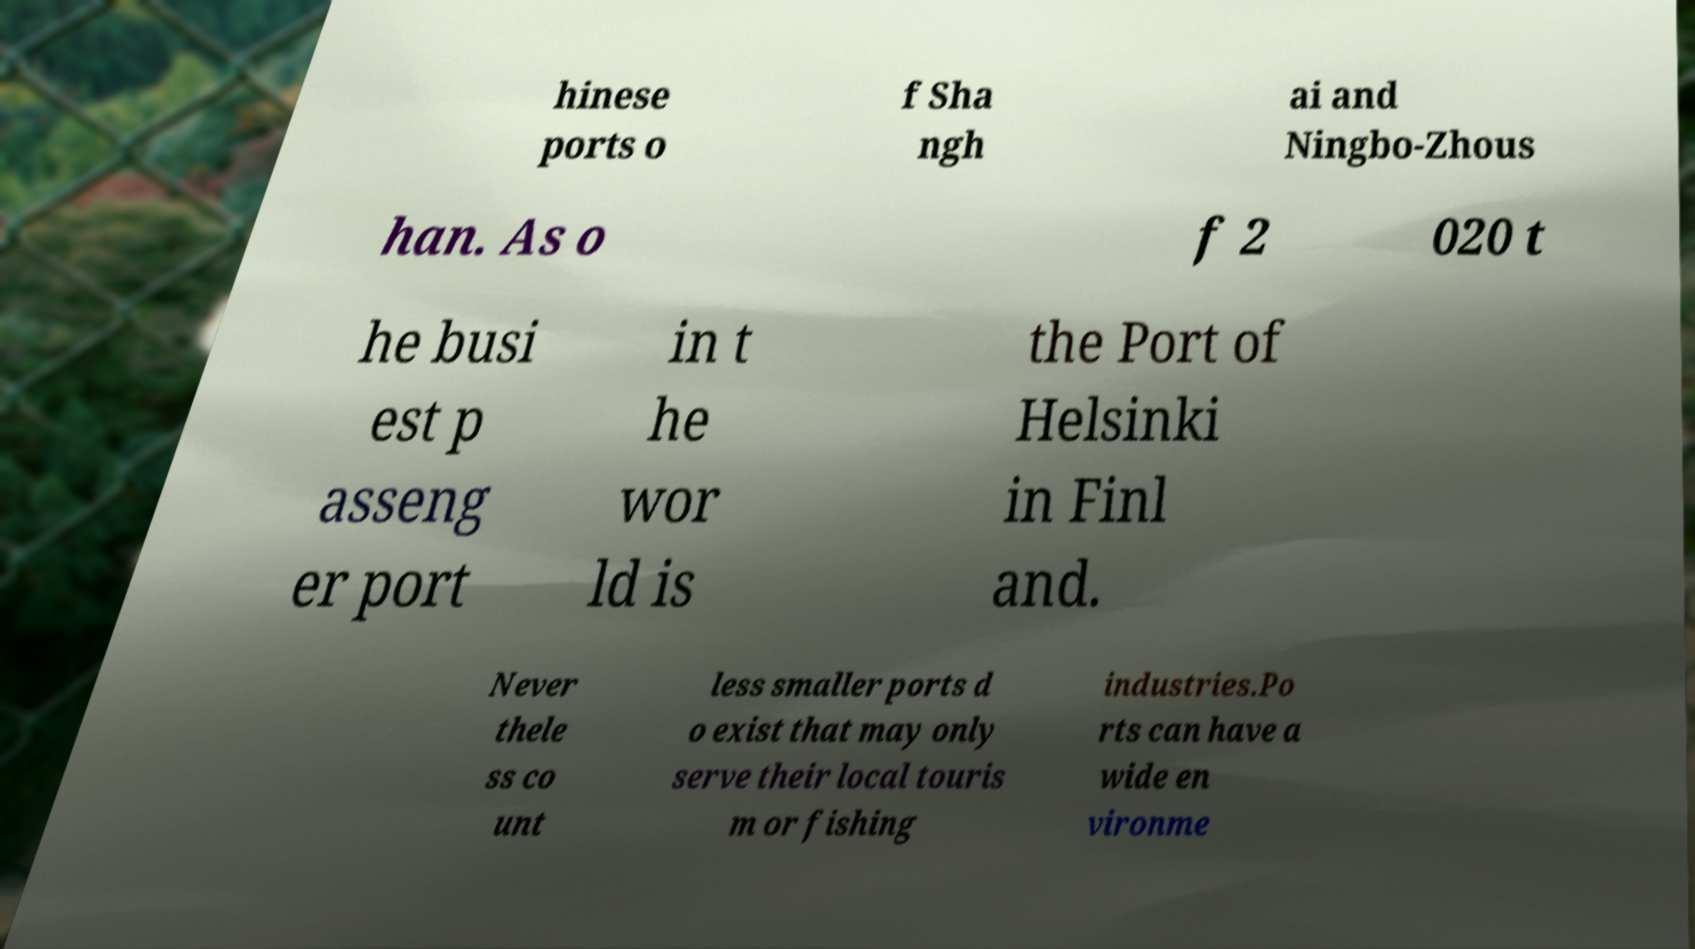Could you assist in decoding the text presented in this image and type it out clearly? hinese ports o f Sha ngh ai and Ningbo-Zhous han. As o f 2 020 t he busi est p asseng er port in t he wor ld is the Port of Helsinki in Finl and. Never thele ss co unt less smaller ports d o exist that may only serve their local touris m or fishing industries.Po rts can have a wide en vironme 